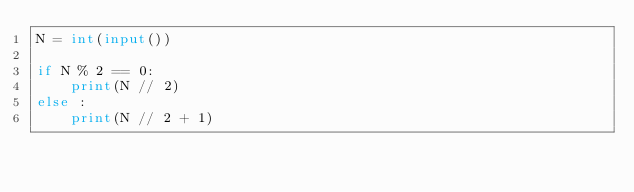<code> <loc_0><loc_0><loc_500><loc_500><_Python_>N = int(input())

if N % 2 == 0:
    print(N // 2)
else :
    print(N // 2 + 1)</code> 